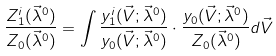<formula> <loc_0><loc_0><loc_500><loc_500>\frac { Z ^ { i } _ { 1 } ( \vec { \lambda } ^ { 0 } ) } { Z _ { 0 } ( \vec { \lambda } ^ { 0 } ) } = \int \frac { y _ { 1 } ^ { i } ( \vec { V } ; \vec { \lambda } ^ { 0 } ) } { y _ { 0 } ( \vec { V } ; \vec { \lambda } ^ { 0 } ) } \cdot \frac { y _ { 0 } ( \vec { V } ; \vec { \lambda } ^ { 0 } ) } { Z _ { 0 } ( \vec { \lambda } ^ { 0 } ) } d \vec { V }</formula> 